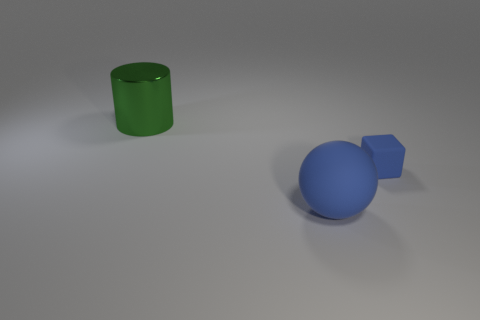Add 2 gray rubber things. How many objects exist? 5 Subtract all cylinders. How many objects are left? 2 Add 2 rubber balls. How many rubber balls exist? 3 Subtract 1 blue balls. How many objects are left? 2 Subtract all purple cylinders. Subtract all large spheres. How many objects are left? 2 Add 1 blocks. How many blocks are left? 2 